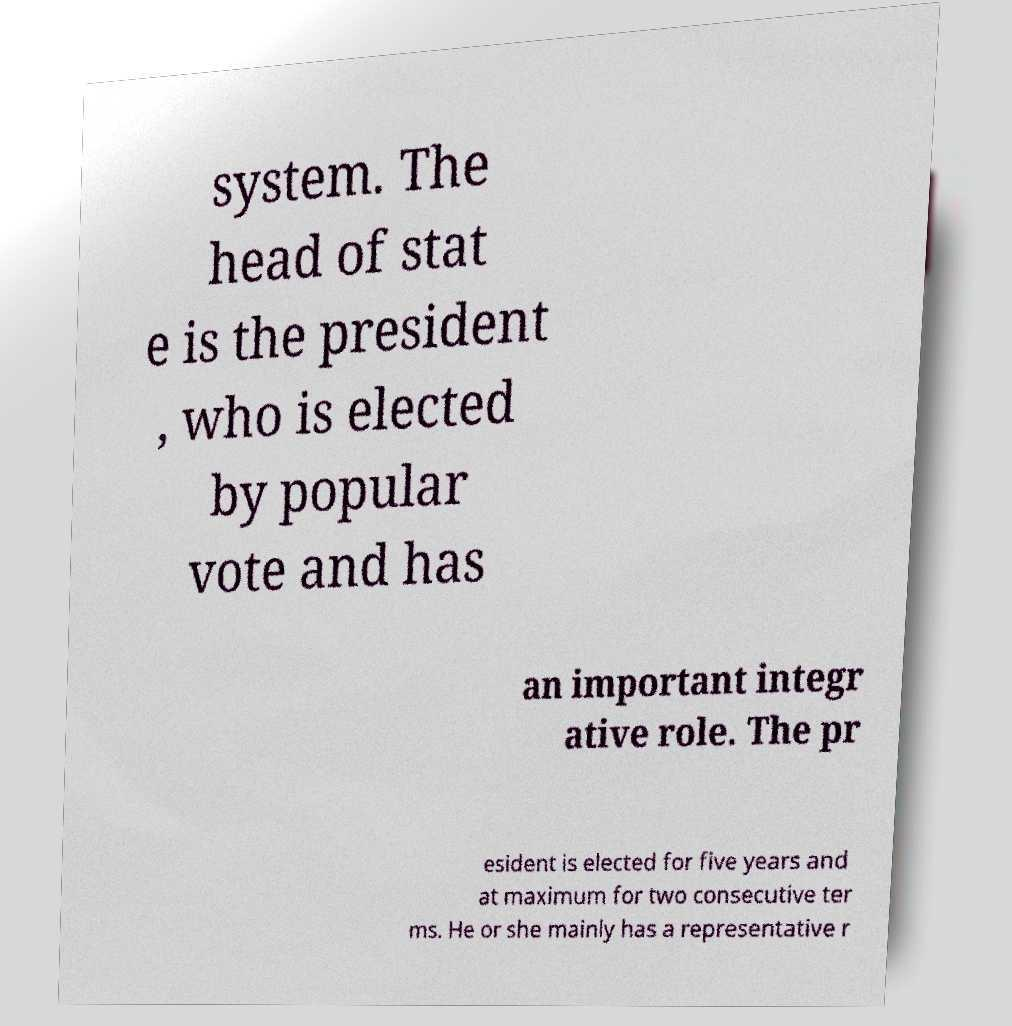There's text embedded in this image that I need extracted. Can you transcribe it verbatim? system. The head of stat e is the president , who is elected by popular vote and has an important integr ative role. The pr esident is elected for five years and at maximum for two consecutive ter ms. He or she mainly has a representative r 